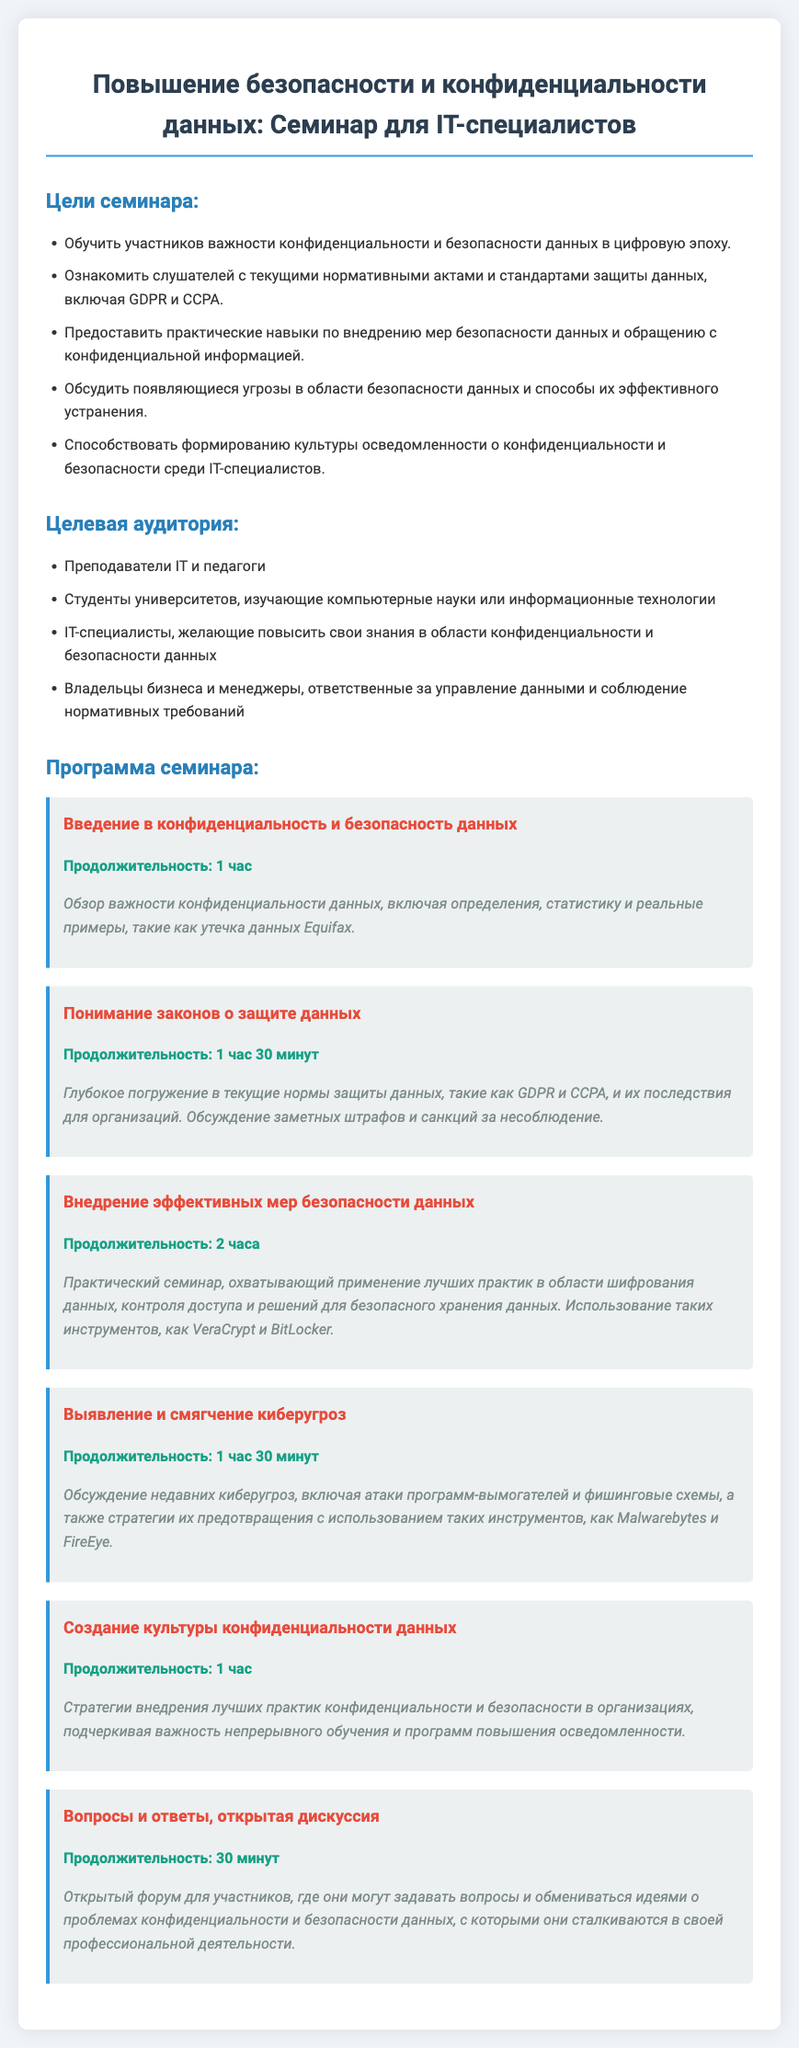что такое тема семинара? Тема семинара указана в заголовке: "Повышение безопасности и конфиденциальности данных: Семинар для IT-специалистов".
Answer: Повышение безопасности и конфиденциальности данных какова продолжительность семинара по внедрению эффективных мер безопасности данных? В документе указана продолжительность этого семинара как 2 часа.
Answer: 2 часа кто входит в целевую аудиторию семинара? В документе перечислены представители целевой аудитории, такие как преподаватели IT и студенты, изучающие компьютерные науки.
Answer: Преподаватели IT и студенты какие темы будут обсуждаться на семинаре? Документ описывает несколько отдельных сессий, таких как "Введение в конфиденциальность и безопасность данных" и "Выявление и смягчение киберугроз".
Answer: Введение в конфиденциальность и безопасность данных, Выявление и смягчение киберугроз сколько времени отведено на сессию "Вопросы и ответы, открытая дискуссия"? Продолжительность этой сессии указана как 30 минут.
Answer: 30 минут какова цель семинара? Цели семинара перечислены в документе, включая обучение участников важности конфиденциальности данных.
Answer: Обучить участников важности конфиденциальности и безопасности данных в цифровую эпоху 